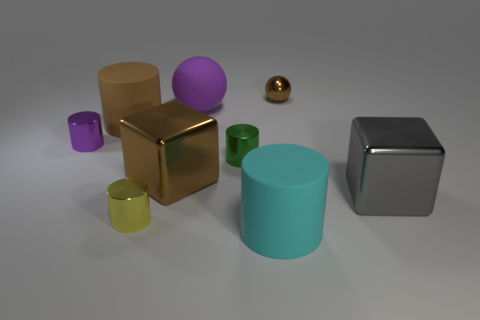Subtract 1 cylinders. How many cylinders are left? 4 Subtract all purple cylinders. How many cylinders are left? 4 Subtract all green metallic cylinders. How many cylinders are left? 4 Subtract all gray cylinders. Subtract all purple balls. How many cylinders are left? 5 Add 1 big brown rubber cylinders. How many objects exist? 10 Subtract all cubes. How many objects are left? 7 Add 1 tiny gray matte cubes. How many tiny gray matte cubes exist? 1 Subtract 1 cyan cylinders. How many objects are left? 8 Subtract all small yellow shiny cylinders. Subtract all large brown rubber objects. How many objects are left? 7 Add 6 large cylinders. How many large cylinders are left? 8 